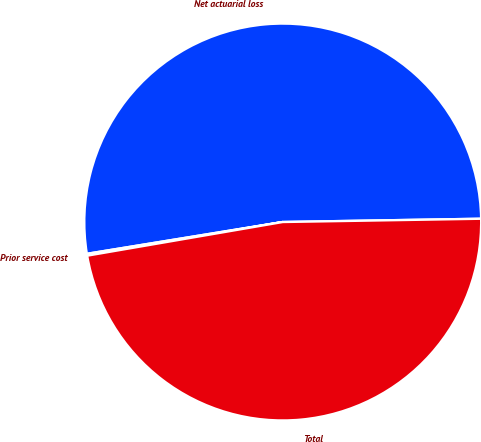<chart> <loc_0><loc_0><loc_500><loc_500><pie_chart><fcel>Net actuarial loss<fcel>Prior service cost<fcel>Total<nl><fcel>52.3%<fcel>0.15%<fcel>47.55%<nl></chart> 